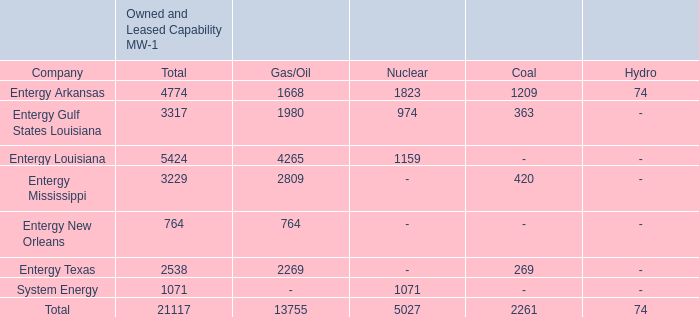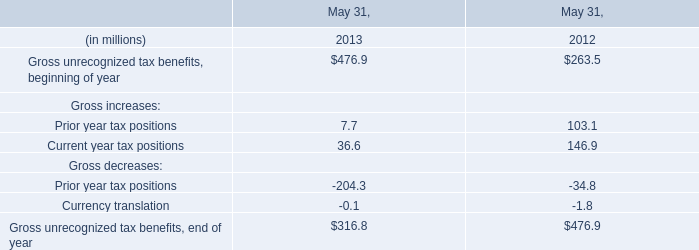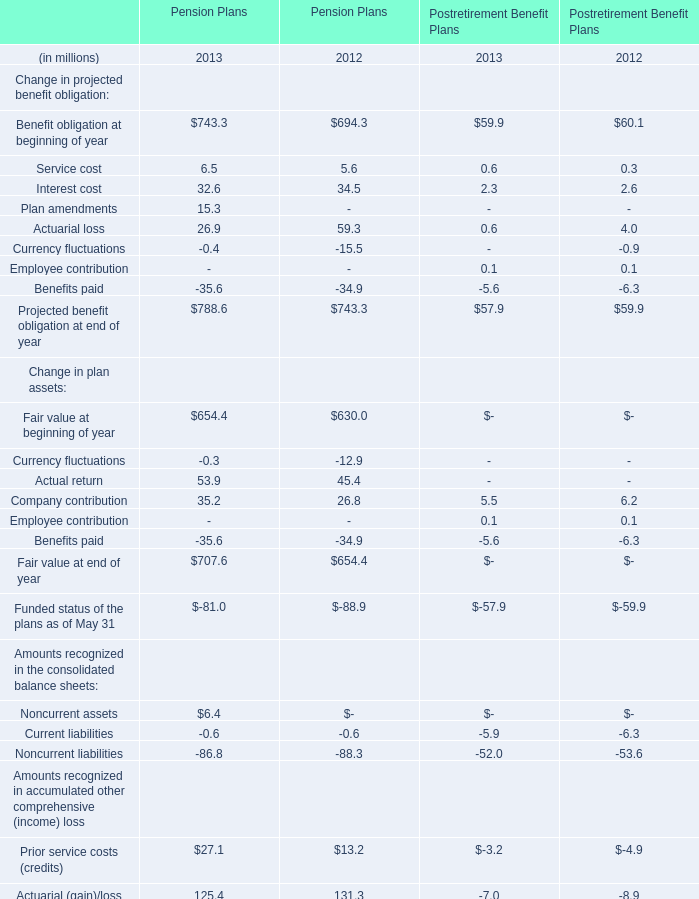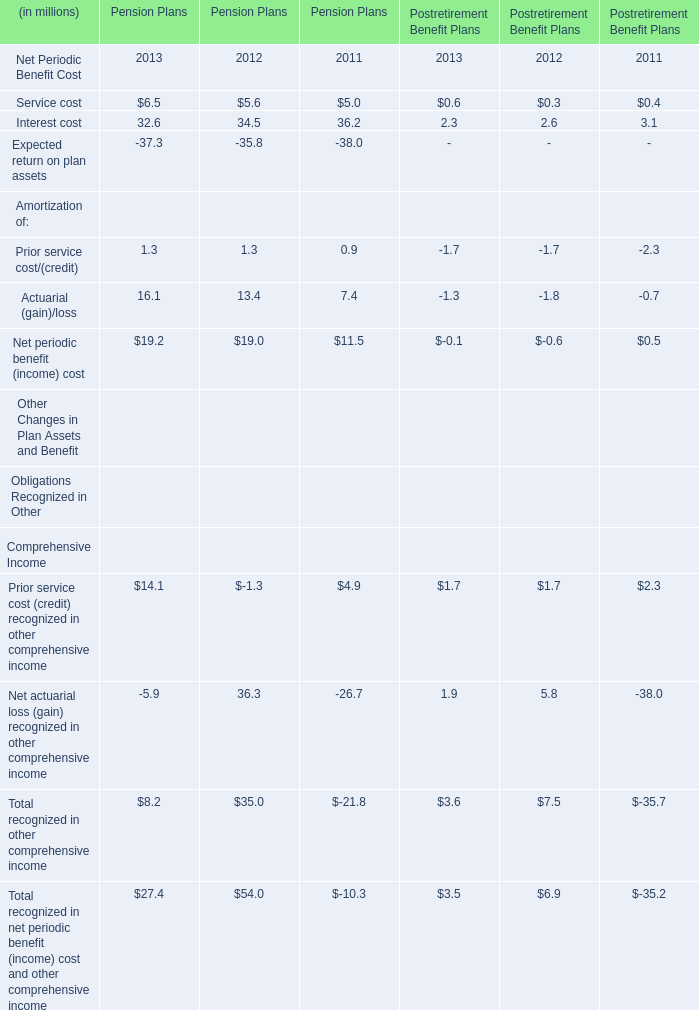How many element exceed the average of Interest cost for Pension Plans? 
Answer: 3. 